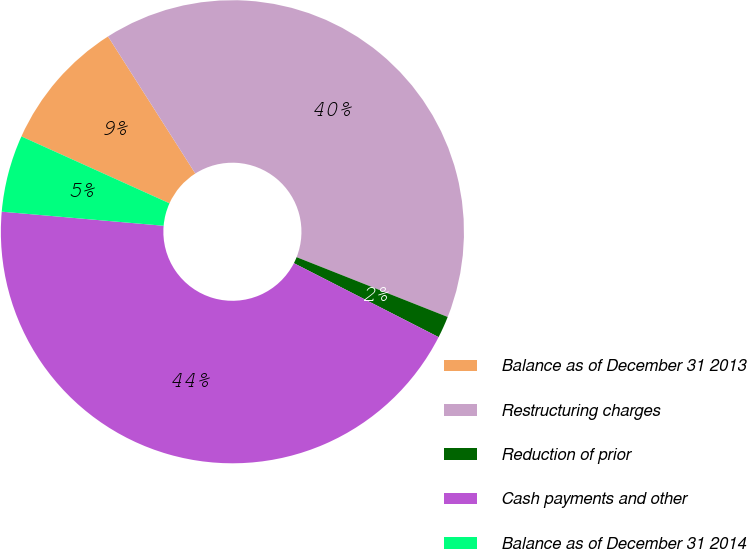Convert chart to OTSL. <chart><loc_0><loc_0><loc_500><loc_500><pie_chart><fcel>Balance as of December 31 2013<fcel>Restructuring charges<fcel>Reduction of prior<fcel>Cash payments and other<fcel>Balance as of December 31 2014<nl><fcel>9.22%<fcel>40.02%<fcel>1.52%<fcel>43.86%<fcel>5.37%<nl></chart> 